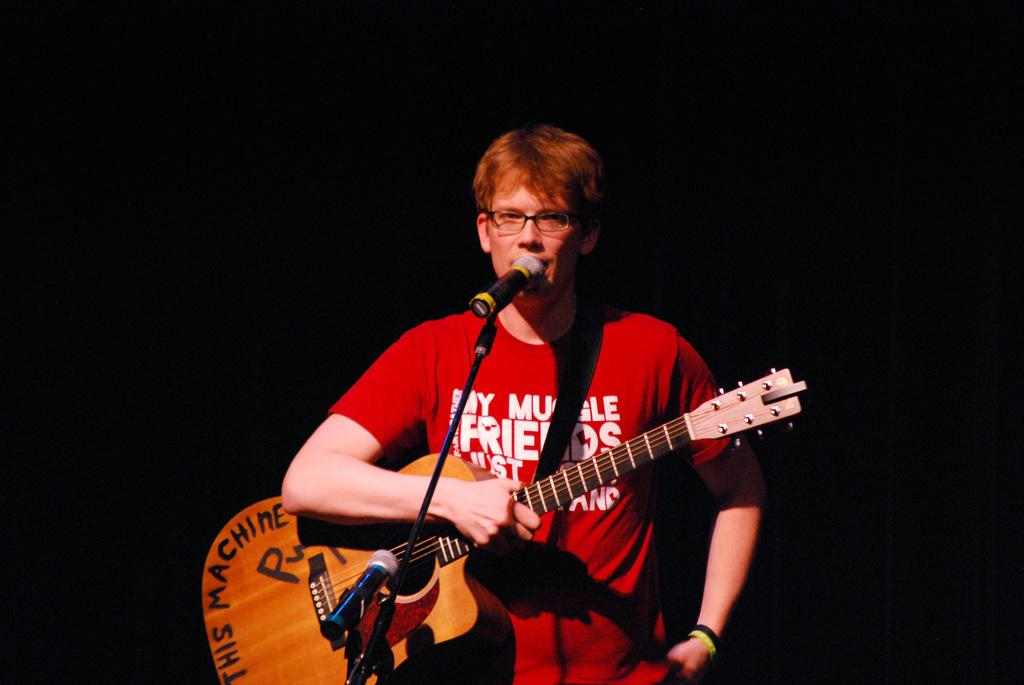What is the man in the image doing? The man is standing in front of a mic. What instrument is the man holding? The man is holding a guitar. Where is the guitar placed in relation to the man? The guitar is in the man's hat. What type of eyewear is the man wearing? The man is wearing spectacles. Can you tell me how many birds are perched on the man's shoulder in the image? There are no birds present in the image; the man is holding a guitar in his hat. Is there a stream visible in the background of the image? There is no mention of a stream in the provided facts, and no such element is visible in the image. 